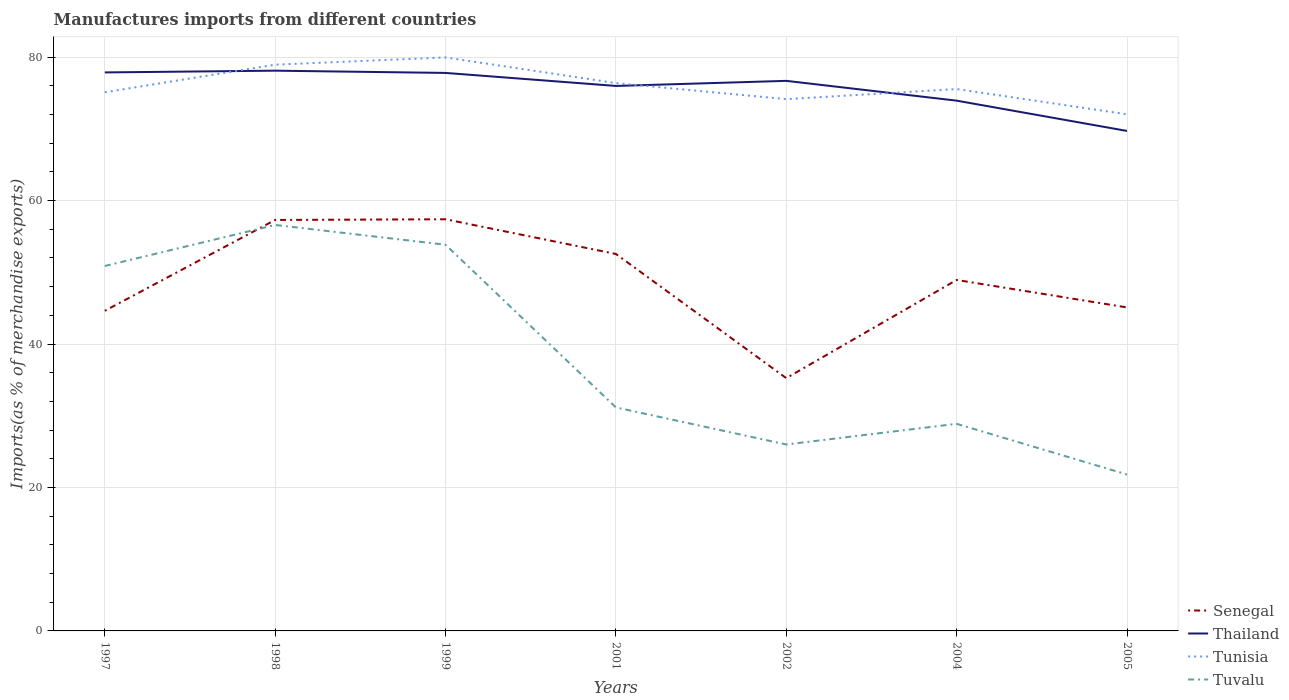Does the line corresponding to Tunisia intersect with the line corresponding to Thailand?
Provide a succinct answer. Yes. Is the number of lines equal to the number of legend labels?
Offer a terse response. Yes. Across all years, what is the maximum percentage of imports to different countries in Senegal?
Give a very brief answer. 35.24. What is the total percentage of imports to different countries in Tuvalu in the graph?
Your response must be concise. 9.35. What is the difference between the highest and the second highest percentage of imports to different countries in Thailand?
Give a very brief answer. 8.4. How many lines are there?
Offer a very short reply. 4. How many years are there in the graph?
Your answer should be compact. 7. Are the values on the major ticks of Y-axis written in scientific E-notation?
Your answer should be compact. No. Does the graph contain any zero values?
Your answer should be compact. No. Where does the legend appear in the graph?
Your answer should be very brief. Bottom right. How many legend labels are there?
Your response must be concise. 4. How are the legend labels stacked?
Give a very brief answer. Vertical. What is the title of the graph?
Provide a succinct answer. Manufactures imports from different countries. Does "Middle East & North Africa (all income levels)" appear as one of the legend labels in the graph?
Provide a succinct answer. No. What is the label or title of the X-axis?
Your answer should be very brief. Years. What is the label or title of the Y-axis?
Keep it short and to the point. Imports(as % of merchandise exports). What is the Imports(as % of merchandise exports) of Senegal in 1997?
Your response must be concise. 44.63. What is the Imports(as % of merchandise exports) in Thailand in 1997?
Ensure brevity in your answer.  77.87. What is the Imports(as % of merchandise exports) of Tunisia in 1997?
Give a very brief answer. 75.11. What is the Imports(as % of merchandise exports) in Tuvalu in 1997?
Provide a short and direct response. 50.88. What is the Imports(as % of merchandise exports) of Senegal in 1998?
Your answer should be very brief. 57.3. What is the Imports(as % of merchandise exports) of Thailand in 1998?
Make the answer very short. 78.12. What is the Imports(as % of merchandise exports) of Tunisia in 1998?
Your response must be concise. 78.95. What is the Imports(as % of merchandise exports) of Tuvalu in 1998?
Offer a very short reply. 56.6. What is the Imports(as % of merchandise exports) of Senegal in 1999?
Keep it short and to the point. 57.4. What is the Imports(as % of merchandise exports) in Thailand in 1999?
Your answer should be compact. 77.8. What is the Imports(as % of merchandise exports) of Tunisia in 1999?
Offer a terse response. 79.96. What is the Imports(as % of merchandise exports) in Tuvalu in 1999?
Keep it short and to the point. 53.85. What is the Imports(as % of merchandise exports) in Senegal in 2001?
Provide a succinct answer. 52.56. What is the Imports(as % of merchandise exports) of Thailand in 2001?
Make the answer very short. 75.99. What is the Imports(as % of merchandise exports) of Tunisia in 2001?
Offer a very short reply. 76.38. What is the Imports(as % of merchandise exports) in Tuvalu in 2001?
Ensure brevity in your answer.  31.16. What is the Imports(as % of merchandise exports) of Senegal in 2002?
Provide a succinct answer. 35.24. What is the Imports(as % of merchandise exports) in Thailand in 2002?
Your answer should be compact. 76.7. What is the Imports(as % of merchandise exports) in Tunisia in 2002?
Give a very brief answer. 74.14. What is the Imports(as % of merchandise exports) of Tuvalu in 2002?
Make the answer very short. 25.99. What is the Imports(as % of merchandise exports) of Senegal in 2004?
Offer a terse response. 48.93. What is the Imports(as % of merchandise exports) of Thailand in 2004?
Keep it short and to the point. 73.94. What is the Imports(as % of merchandise exports) in Tunisia in 2004?
Provide a succinct answer. 75.55. What is the Imports(as % of merchandise exports) of Tuvalu in 2004?
Ensure brevity in your answer.  28.88. What is the Imports(as % of merchandise exports) of Senegal in 2005?
Give a very brief answer. 45.1. What is the Imports(as % of merchandise exports) in Thailand in 2005?
Keep it short and to the point. 69.71. What is the Imports(as % of merchandise exports) of Tunisia in 2005?
Make the answer very short. 72.03. What is the Imports(as % of merchandise exports) in Tuvalu in 2005?
Your response must be concise. 21.81. Across all years, what is the maximum Imports(as % of merchandise exports) in Senegal?
Keep it short and to the point. 57.4. Across all years, what is the maximum Imports(as % of merchandise exports) in Thailand?
Keep it short and to the point. 78.12. Across all years, what is the maximum Imports(as % of merchandise exports) in Tunisia?
Your response must be concise. 79.96. Across all years, what is the maximum Imports(as % of merchandise exports) in Tuvalu?
Give a very brief answer. 56.6. Across all years, what is the minimum Imports(as % of merchandise exports) of Senegal?
Your answer should be compact. 35.24. Across all years, what is the minimum Imports(as % of merchandise exports) in Thailand?
Ensure brevity in your answer.  69.71. Across all years, what is the minimum Imports(as % of merchandise exports) in Tunisia?
Provide a succinct answer. 72.03. Across all years, what is the minimum Imports(as % of merchandise exports) of Tuvalu?
Offer a terse response. 21.81. What is the total Imports(as % of merchandise exports) in Senegal in the graph?
Ensure brevity in your answer.  341.17. What is the total Imports(as % of merchandise exports) in Thailand in the graph?
Offer a terse response. 530.12. What is the total Imports(as % of merchandise exports) in Tunisia in the graph?
Ensure brevity in your answer.  532.14. What is the total Imports(as % of merchandise exports) in Tuvalu in the graph?
Make the answer very short. 269.17. What is the difference between the Imports(as % of merchandise exports) of Senegal in 1997 and that in 1998?
Offer a terse response. -12.67. What is the difference between the Imports(as % of merchandise exports) of Thailand in 1997 and that in 1998?
Give a very brief answer. -0.24. What is the difference between the Imports(as % of merchandise exports) in Tunisia in 1997 and that in 1998?
Offer a very short reply. -3.85. What is the difference between the Imports(as % of merchandise exports) in Tuvalu in 1997 and that in 1998?
Make the answer very short. -5.72. What is the difference between the Imports(as % of merchandise exports) of Senegal in 1997 and that in 1999?
Your response must be concise. -12.76. What is the difference between the Imports(as % of merchandise exports) of Thailand in 1997 and that in 1999?
Keep it short and to the point. 0.07. What is the difference between the Imports(as % of merchandise exports) of Tunisia in 1997 and that in 1999?
Provide a succinct answer. -4.85. What is the difference between the Imports(as % of merchandise exports) of Tuvalu in 1997 and that in 1999?
Your response must be concise. -2.96. What is the difference between the Imports(as % of merchandise exports) in Senegal in 1997 and that in 2001?
Your answer should be very brief. -7.93. What is the difference between the Imports(as % of merchandise exports) in Thailand in 1997 and that in 2001?
Keep it short and to the point. 1.89. What is the difference between the Imports(as % of merchandise exports) in Tunisia in 1997 and that in 2001?
Your answer should be compact. -1.28. What is the difference between the Imports(as % of merchandise exports) in Tuvalu in 1997 and that in 2001?
Keep it short and to the point. 19.72. What is the difference between the Imports(as % of merchandise exports) of Senegal in 1997 and that in 2002?
Your answer should be compact. 9.39. What is the difference between the Imports(as % of merchandise exports) of Thailand in 1997 and that in 2002?
Provide a short and direct response. 1.18. What is the difference between the Imports(as % of merchandise exports) of Tunisia in 1997 and that in 2002?
Make the answer very short. 0.96. What is the difference between the Imports(as % of merchandise exports) of Tuvalu in 1997 and that in 2002?
Provide a succinct answer. 24.89. What is the difference between the Imports(as % of merchandise exports) in Senegal in 1997 and that in 2004?
Give a very brief answer. -4.3. What is the difference between the Imports(as % of merchandise exports) of Thailand in 1997 and that in 2004?
Provide a short and direct response. 3.94. What is the difference between the Imports(as % of merchandise exports) in Tunisia in 1997 and that in 2004?
Provide a short and direct response. -0.45. What is the difference between the Imports(as % of merchandise exports) in Tuvalu in 1997 and that in 2004?
Your response must be concise. 22. What is the difference between the Imports(as % of merchandise exports) in Senegal in 1997 and that in 2005?
Offer a very short reply. -0.47. What is the difference between the Imports(as % of merchandise exports) in Thailand in 1997 and that in 2005?
Your response must be concise. 8.16. What is the difference between the Imports(as % of merchandise exports) of Tunisia in 1997 and that in 2005?
Your response must be concise. 3.07. What is the difference between the Imports(as % of merchandise exports) in Tuvalu in 1997 and that in 2005?
Ensure brevity in your answer.  29.07. What is the difference between the Imports(as % of merchandise exports) of Senegal in 1998 and that in 1999?
Ensure brevity in your answer.  -0.09. What is the difference between the Imports(as % of merchandise exports) of Thailand in 1998 and that in 1999?
Keep it short and to the point. 0.31. What is the difference between the Imports(as % of merchandise exports) of Tunisia in 1998 and that in 1999?
Your answer should be compact. -1.01. What is the difference between the Imports(as % of merchandise exports) in Tuvalu in 1998 and that in 1999?
Your answer should be very brief. 2.76. What is the difference between the Imports(as % of merchandise exports) in Senegal in 1998 and that in 2001?
Your answer should be compact. 4.74. What is the difference between the Imports(as % of merchandise exports) in Thailand in 1998 and that in 2001?
Your answer should be compact. 2.13. What is the difference between the Imports(as % of merchandise exports) of Tunisia in 1998 and that in 2001?
Make the answer very short. 2.57. What is the difference between the Imports(as % of merchandise exports) in Tuvalu in 1998 and that in 2001?
Provide a succinct answer. 25.44. What is the difference between the Imports(as % of merchandise exports) of Senegal in 1998 and that in 2002?
Offer a very short reply. 22.06. What is the difference between the Imports(as % of merchandise exports) of Thailand in 1998 and that in 2002?
Offer a very short reply. 1.42. What is the difference between the Imports(as % of merchandise exports) of Tunisia in 1998 and that in 2002?
Give a very brief answer. 4.81. What is the difference between the Imports(as % of merchandise exports) in Tuvalu in 1998 and that in 2002?
Make the answer very short. 30.61. What is the difference between the Imports(as % of merchandise exports) of Senegal in 1998 and that in 2004?
Your answer should be very brief. 8.37. What is the difference between the Imports(as % of merchandise exports) in Thailand in 1998 and that in 2004?
Keep it short and to the point. 4.18. What is the difference between the Imports(as % of merchandise exports) of Tunisia in 1998 and that in 2004?
Give a very brief answer. 3.4. What is the difference between the Imports(as % of merchandise exports) in Tuvalu in 1998 and that in 2004?
Your response must be concise. 27.73. What is the difference between the Imports(as % of merchandise exports) of Senegal in 1998 and that in 2005?
Provide a succinct answer. 12.2. What is the difference between the Imports(as % of merchandise exports) in Thailand in 1998 and that in 2005?
Give a very brief answer. 8.4. What is the difference between the Imports(as % of merchandise exports) in Tunisia in 1998 and that in 2005?
Provide a short and direct response. 6.92. What is the difference between the Imports(as % of merchandise exports) of Tuvalu in 1998 and that in 2005?
Offer a terse response. 34.79. What is the difference between the Imports(as % of merchandise exports) of Senegal in 1999 and that in 2001?
Ensure brevity in your answer.  4.84. What is the difference between the Imports(as % of merchandise exports) in Thailand in 1999 and that in 2001?
Ensure brevity in your answer.  1.82. What is the difference between the Imports(as % of merchandise exports) in Tunisia in 1999 and that in 2001?
Provide a short and direct response. 3.58. What is the difference between the Imports(as % of merchandise exports) of Tuvalu in 1999 and that in 2001?
Your response must be concise. 22.68. What is the difference between the Imports(as % of merchandise exports) of Senegal in 1999 and that in 2002?
Provide a succinct answer. 22.15. What is the difference between the Imports(as % of merchandise exports) in Thailand in 1999 and that in 2002?
Provide a short and direct response. 1.11. What is the difference between the Imports(as % of merchandise exports) of Tunisia in 1999 and that in 2002?
Offer a very short reply. 5.82. What is the difference between the Imports(as % of merchandise exports) of Tuvalu in 1999 and that in 2002?
Your answer should be very brief. 27.85. What is the difference between the Imports(as % of merchandise exports) in Senegal in 1999 and that in 2004?
Your response must be concise. 8.46. What is the difference between the Imports(as % of merchandise exports) in Thailand in 1999 and that in 2004?
Your answer should be compact. 3.87. What is the difference between the Imports(as % of merchandise exports) of Tunisia in 1999 and that in 2004?
Make the answer very short. 4.41. What is the difference between the Imports(as % of merchandise exports) in Tuvalu in 1999 and that in 2004?
Your response must be concise. 24.97. What is the difference between the Imports(as % of merchandise exports) in Senegal in 1999 and that in 2005?
Your response must be concise. 12.29. What is the difference between the Imports(as % of merchandise exports) of Thailand in 1999 and that in 2005?
Offer a very short reply. 8.09. What is the difference between the Imports(as % of merchandise exports) of Tunisia in 1999 and that in 2005?
Ensure brevity in your answer.  7.93. What is the difference between the Imports(as % of merchandise exports) of Tuvalu in 1999 and that in 2005?
Your answer should be very brief. 32.03. What is the difference between the Imports(as % of merchandise exports) in Senegal in 2001 and that in 2002?
Keep it short and to the point. 17.31. What is the difference between the Imports(as % of merchandise exports) of Thailand in 2001 and that in 2002?
Your answer should be compact. -0.71. What is the difference between the Imports(as % of merchandise exports) of Tunisia in 2001 and that in 2002?
Your response must be concise. 2.24. What is the difference between the Imports(as % of merchandise exports) in Tuvalu in 2001 and that in 2002?
Your answer should be very brief. 5.17. What is the difference between the Imports(as % of merchandise exports) of Senegal in 2001 and that in 2004?
Make the answer very short. 3.63. What is the difference between the Imports(as % of merchandise exports) in Thailand in 2001 and that in 2004?
Your answer should be very brief. 2.05. What is the difference between the Imports(as % of merchandise exports) in Tunisia in 2001 and that in 2004?
Your answer should be very brief. 0.83. What is the difference between the Imports(as % of merchandise exports) of Tuvalu in 2001 and that in 2004?
Keep it short and to the point. 2.28. What is the difference between the Imports(as % of merchandise exports) in Senegal in 2001 and that in 2005?
Your answer should be very brief. 7.46. What is the difference between the Imports(as % of merchandise exports) in Thailand in 2001 and that in 2005?
Your answer should be compact. 6.27. What is the difference between the Imports(as % of merchandise exports) in Tunisia in 2001 and that in 2005?
Make the answer very short. 4.35. What is the difference between the Imports(as % of merchandise exports) in Tuvalu in 2001 and that in 2005?
Provide a succinct answer. 9.35. What is the difference between the Imports(as % of merchandise exports) in Senegal in 2002 and that in 2004?
Offer a very short reply. -13.69. What is the difference between the Imports(as % of merchandise exports) of Thailand in 2002 and that in 2004?
Your answer should be very brief. 2.76. What is the difference between the Imports(as % of merchandise exports) of Tunisia in 2002 and that in 2004?
Provide a short and direct response. -1.41. What is the difference between the Imports(as % of merchandise exports) in Tuvalu in 2002 and that in 2004?
Ensure brevity in your answer.  -2.88. What is the difference between the Imports(as % of merchandise exports) in Senegal in 2002 and that in 2005?
Offer a very short reply. -9.86. What is the difference between the Imports(as % of merchandise exports) in Thailand in 2002 and that in 2005?
Provide a short and direct response. 6.98. What is the difference between the Imports(as % of merchandise exports) of Tunisia in 2002 and that in 2005?
Provide a short and direct response. 2.11. What is the difference between the Imports(as % of merchandise exports) of Tuvalu in 2002 and that in 2005?
Provide a short and direct response. 4.18. What is the difference between the Imports(as % of merchandise exports) of Senegal in 2004 and that in 2005?
Offer a terse response. 3.83. What is the difference between the Imports(as % of merchandise exports) of Thailand in 2004 and that in 2005?
Offer a terse response. 4.22. What is the difference between the Imports(as % of merchandise exports) of Tunisia in 2004 and that in 2005?
Provide a succinct answer. 3.52. What is the difference between the Imports(as % of merchandise exports) in Tuvalu in 2004 and that in 2005?
Give a very brief answer. 7.07. What is the difference between the Imports(as % of merchandise exports) in Senegal in 1997 and the Imports(as % of merchandise exports) in Thailand in 1998?
Ensure brevity in your answer.  -33.48. What is the difference between the Imports(as % of merchandise exports) in Senegal in 1997 and the Imports(as % of merchandise exports) in Tunisia in 1998?
Offer a very short reply. -34.32. What is the difference between the Imports(as % of merchandise exports) of Senegal in 1997 and the Imports(as % of merchandise exports) of Tuvalu in 1998?
Your response must be concise. -11.97. What is the difference between the Imports(as % of merchandise exports) of Thailand in 1997 and the Imports(as % of merchandise exports) of Tunisia in 1998?
Provide a short and direct response. -1.08. What is the difference between the Imports(as % of merchandise exports) of Thailand in 1997 and the Imports(as % of merchandise exports) of Tuvalu in 1998?
Give a very brief answer. 21.27. What is the difference between the Imports(as % of merchandise exports) of Tunisia in 1997 and the Imports(as % of merchandise exports) of Tuvalu in 1998?
Your answer should be very brief. 18.5. What is the difference between the Imports(as % of merchandise exports) of Senegal in 1997 and the Imports(as % of merchandise exports) of Thailand in 1999?
Offer a very short reply. -33.17. What is the difference between the Imports(as % of merchandise exports) in Senegal in 1997 and the Imports(as % of merchandise exports) in Tunisia in 1999?
Your response must be concise. -35.33. What is the difference between the Imports(as % of merchandise exports) of Senegal in 1997 and the Imports(as % of merchandise exports) of Tuvalu in 1999?
Give a very brief answer. -9.21. What is the difference between the Imports(as % of merchandise exports) in Thailand in 1997 and the Imports(as % of merchandise exports) in Tunisia in 1999?
Give a very brief answer. -2.09. What is the difference between the Imports(as % of merchandise exports) of Thailand in 1997 and the Imports(as % of merchandise exports) of Tuvalu in 1999?
Give a very brief answer. 24.03. What is the difference between the Imports(as % of merchandise exports) in Tunisia in 1997 and the Imports(as % of merchandise exports) in Tuvalu in 1999?
Ensure brevity in your answer.  21.26. What is the difference between the Imports(as % of merchandise exports) in Senegal in 1997 and the Imports(as % of merchandise exports) in Thailand in 2001?
Your answer should be very brief. -31.35. What is the difference between the Imports(as % of merchandise exports) of Senegal in 1997 and the Imports(as % of merchandise exports) of Tunisia in 2001?
Keep it short and to the point. -31.75. What is the difference between the Imports(as % of merchandise exports) in Senegal in 1997 and the Imports(as % of merchandise exports) in Tuvalu in 2001?
Provide a short and direct response. 13.47. What is the difference between the Imports(as % of merchandise exports) of Thailand in 1997 and the Imports(as % of merchandise exports) of Tunisia in 2001?
Make the answer very short. 1.49. What is the difference between the Imports(as % of merchandise exports) in Thailand in 1997 and the Imports(as % of merchandise exports) in Tuvalu in 2001?
Provide a succinct answer. 46.71. What is the difference between the Imports(as % of merchandise exports) of Tunisia in 1997 and the Imports(as % of merchandise exports) of Tuvalu in 2001?
Your response must be concise. 43.95. What is the difference between the Imports(as % of merchandise exports) in Senegal in 1997 and the Imports(as % of merchandise exports) in Thailand in 2002?
Your response must be concise. -32.06. What is the difference between the Imports(as % of merchandise exports) in Senegal in 1997 and the Imports(as % of merchandise exports) in Tunisia in 2002?
Your response must be concise. -29.51. What is the difference between the Imports(as % of merchandise exports) of Senegal in 1997 and the Imports(as % of merchandise exports) of Tuvalu in 2002?
Offer a terse response. 18.64. What is the difference between the Imports(as % of merchandise exports) in Thailand in 1997 and the Imports(as % of merchandise exports) in Tunisia in 2002?
Ensure brevity in your answer.  3.73. What is the difference between the Imports(as % of merchandise exports) of Thailand in 1997 and the Imports(as % of merchandise exports) of Tuvalu in 2002?
Provide a short and direct response. 51.88. What is the difference between the Imports(as % of merchandise exports) in Tunisia in 1997 and the Imports(as % of merchandise exports) in Tuvalu in 2002?
Ensure brevity in your answer.  49.11. What is the difference between the Imports(as % of merchandise exports) in Senegal in 1997 and the Imports(as % of merchandise exports) in Thailand in 2004?
Your answer should be compact. -29.3. What is the difference between the Imports(as % of merchandise exports) in Senegal in 1997 and the Imports(as % of merchandise exports) in Tunisia in 2004?
Ensure brevity in your answer.  -30.92. What is the difference between the Imports(as % of merchandise exports) of Senegal in 1997 and the Imports(as % of merchandise exports) of Tuvalu in 2004?
Keep it short and to the point. 15.76. What is the difference between the Imports(as % of merchandise exports) of Thailand in 1997 and the Imports(as % of merchandise exports) of Tunisia in 2004?
Keep it short and to the point. 2.32. What is the difference between the Imports(as % of merchandise exports) in Thailand in 1997 and the Imports(as % of merchandise exports) in Tuvalu in 2004?
Provide a succinct answer. 49. What is the difference between the Imports(as % of merchandise exports) in Tunisia in 1997 and the Imports(as % of merchandise exports) in Tuvalu in 2004?
Your answer should be very brief. 46.23. What is the difference between the Imports(as % of merchandise exports) of Senegal in 1997 and the Imports(as % of merchandise exports) of Thailand in 2005?
Provide a short and direct response. -25.08. What is the difference between the Imports(as % of merchandise exports) in Senegal in 1997 and the Imports(as % of merchandise exports) in Tunisia in 2005?
Ensure brevity in your answer.  -27.4. What is the difference between the Imports(as % of merchandise exports) in Senegal in 1997 and the Imports(as % of merchandise exports) in Tuvalu in 2005?
Your answer should be very brief. 22.82. What is the difference between the Imports(as % of merchandise exports) of Thailand in 1997 and the Imports(as % of merchandise exports) of Tunisia in 2005?
Offer a terse response. 5.84. What is the difference between the Imports(as % of merchandise exports) in Thailand in 1997 and the Imports(as % of merchandise exports) in Tuvalu in 2005?
Provide a short and direct response. 56.06. What is the difference between the Imports(as % of merchandise exports) in Tunisia in 1997 and the Imports(as % of merchandise exports) in Tuvalu in 2005?
Your answer should be very brief. 53.3. What is the difference between the Imports(as % of merchandise exports) of Senegal in 1998 and the Imports(as % of merchandise exports) of Thailand in 1999?
Your response must be concise. -20.5. What is the difference between the Imports(as % of merchandise exports) in Senegal in 1998 and the Imports(as % of merchandise exports) in Tunisia in 1999?
Your answer should be compact. -22.66. What is the difference between the Imports(as % of merchandise exports) in Senegal in 1998 and the Imports(as % of merchandise exports) in Tuvalu in 1999?
Offer a very short reply. 3.46. What is the difference between the Imports(as % of merchandise exports) of Thailand in 1998 and the Imports(as % of merchandise exports) of Tunisia in 1999?
Make the answer very short. -1.85. What is the difference between the Imports(as % of merchandise exports) of Thailand in 1998 and the Imports(as % of merchandise exports) of Tuvalu in 1999?
Ensure brevity in your answer.  24.27. What is the difference between the Imports(as % of merchandise exports) in Tunisia in 1998 and the Imports(as % of merchandise exports) in Tuvalu in 1999?
Ensure brevity in your answer.  25.11. What is the difference between the Imports(as % of merchandise exports) of Senegal in 1998 and the Imports(as % of merchandise exports) of Thailand in 2001?
Offer a very short reply. -18.68. What is the difference between the Imports(as % of merchandise exports) in Senegal in 1998 and the Imports(as % of merchandise exports) in Tunisia in 2001?
Your answer should be very brief. -19.08. What is the difference between the Imports(as % of merchandise exports) in Senegal in 1998 and the Imports(as % of merchandise exports) in Tuvalu in 2001?
Offer a terse response. 26.14. What is the difference between the Imports(as % of merchandise exports) of Thailand in 1998 and the Imports(as % of merchandise exports) of Tunisia in 2001?
Make the answer very short. 1.73. What is the difference between the Imports(as % of merchandise exports) in Thailand in 1998 and the Imports(as % of merchandise exports) in Tuvalu in 2001?
Keep it short and to the point. 46.95. What is the difference between the Imports(as % of merchandise exports) in Tunisia in 1998 and the Imports(as % of merchandise exports) in Tuvalu in 2001?
Your answer should be very brief. 47.79. What is the difference between the Imports(as % of merchandise exports) in Senegal in 1998 and the Imports(as % of merchandise exports) in Thailand in 2002?
Make the answer very short. -19.39. What is the difference between the Imports(as % of merchandise exports) in Senegal in 1998 and the Imports(as % of merchandise exports) in Tunisia in 2002?
Keep it short and to the point. -16.84. What is the difference between the Imports(as % of merchandise exports) in Senegal in 1998 and the Imports(as % of merchandise exports) in Tuvalu in 2002?
Provide a succinct answer. 31.31. What is the difference between the Imports(as % of merchandise exports) in Thailand in 1998 and the Imports(as % of merchandise exports) in Tunisia in 2002?
Give a very brief answer. 3.97. What is the difference between the Imports(as % of merchandise exports) of Thailand in 1998 and the Imports(as % of merchandise exports) of Tuvalu in 2002?
Keep it short and to the point. 52.12. What is the difference between the Imports(as % of merchandise exports) in Tunisia in 1998 and the Imports(as % of merchandise exports) in Tuvalu in 2002?
Your answer should be compact. 52.96. What is the difference between the Imports(as % of merchandise exports) of Senegal in 1998 and the Imports(as % of merchandise exports) of Thailand in 2004?
Keep it short and to the point. -16.63. What is the difference between the Imports(as % of merchandise exports) of Senegal in 1998 and the Imports(as % of merchandise exports) of Tunisia in 2004?
Make the answer very short. -18.25. What is the difference between the Imports(as % of merchandise exports) in Senegal in 1998 and the Imports(as % of merchandise exports) in Tuvalu in 2004?
Make the answer very short. 28.43. What is the difference between the Imports(as % of merchandise exports) of Thailand in 1998 and the Imports(as % of merchandise exports) of Tunisia in 2004?
Give a very brief answer. 2.56. What is the difference between the Imports(as % of merchandise exports) in Thailand in 1998 and the Imports(as % of merchandise exports) in Tuvalu in 2004?
Provide a succinct answer. 49.24. What is the difference between the Imports(as % of merchandise exports) of Tunisia in 1998 and the Imports(as % of merchandise exports) of Tuvalu in 2004?
Ensure brevity in your answer.  50.08. What is the difference between the Imports(as % of merchandise exports) in Senegal in 1998 and the Imports(as % of merchandise exports) in Thailand in 2005?
Give a very brief answer. -12.41. What is the difference between the Imports(as % of merchandise exports) of Senegal in 1998 and the Imports(as % of merchandise exports) of Tunisia in 2005?
Make the answer very short. -14.73. What is the difference between the Imports(as % of merchandise exports) in Senegal in 1998 and the Imports(as % of merchandise exports) in Tuvalu in 2005?
Provide a succinct answer. 35.49. What is the difference between the Imports(as % of merchandise exports) in Thailand in 1998 and the Imports(as % of merchandise exports) in Tunisia in 2005?
Ensure brevity in your answer.  6.08. What is the difference between the Imports(as % of merchandise exports) of Thailand in 1998 and the Imports(as % of merchandise exports) of Tuvalu in 2005?
Your response must be concise. 56.31. What is the difference between the Imports(as % of merchandise exports) in Tunisia in 1998 and the Imports(as % of merchandise exports) in Tuvalu in 2005?
Offer a very short reply. 57.14. What is the difference between the Imports(as % of merchandise exports) in Senegal in 1999 and the Imports(as % of merchandise exports) in Thailand in 2001?
Your answer should be compact. -18.59. What is the difference between the Imports(as % of merchandise exports) of Senegal in 1999 and the Imports(as % of merchandise exports) of Tunisia in 2001?
Keep it short and to the point. -18.99. What is the difference between the Imports(as % of merchandise exports) of Senegal in 1999 and the Imports(as % of merchandise exports) of Tuvalu in 2001?
Give a very brief answer. 26.24. What is the difference between the Imports(as % of merchandise exports) in Thailand in 1999 and the Imports(as % of merchandise exports) in Tunisia in 2001?
Provide a succinct answer. 1.42. What is the difference between the Imports(as % of merchandise exports) of Thailand in 1999 and the Imports(as % of merchandise exports) of Tuvalu in 2001?
Your response must be concise. 46.64. What is the difference between the Imports(as % of merchandise exports) of Tunisia in 1999 and the Imports(as % of merchandise exports) of Tuvalu in 2001?
Offer a terse response. 48.8. What is the difference between the Imports(as % of merchandise exports) in Senegal in 1999 and the Imports(as % of merchandise exports) in Thailand in 2002?
Provide a short and direct response. -19.3. What is the difference between the Imports(as % of merchandise exports) in Senegal in 1999 and the Imports(as % of merchandise exports) in Tunisia in 2002?
Offer a terse response. -16.75. What is the difference between the Imports(as % of merchandise exports) of Senegal in 1999 and the Imports(as % of merchandise exports) of Tuvalu in 2002?
Your answer should be compact. 31.4. What is the difference between the Imports(as % of merchandise exports) in Thailand in 1999 and the Imports(as % of merchandise exports) in Tunisia in 2002?
Your answer should be compact. 3.66. What is the difference between the Imports(as % of merchandise exports) of Thailand in 1999 and the Imports(as % of merchandise exports) of Tuvalu in 2002?
Provide a succinct answer. 51.81. What is the difference between the Imports(as % of merchandise exports) in Tunisia in 1999 and the Imports(as % of merchandise exports) in Tuvalu in 2002?
Provide a succinct answer. 53.97. What is the difference between the Imports(as % of merchandise exports) in Senegal in 1999 and the Imports(as % of merchandise exports) in Thailand in 2004?
Provide a succinct answer. -16.54. What is the difference between the Imports(as % of merchandise exports) in Senegal in 1999 and the Imports(as % of merchandise exports) in Tunisia in 2004?
Make the answer very short. -18.16. What is the difference between the Imports(as % of merchandise exports) of Senegal in 1999 and the Imports(as % of merchandise exports) of Tuvalu in 2004?
Your answer should be very brief. 28.52. What is the difference between the Imports(as % of merchandise exports) in Thailand in 1999 and the Imports(as % of merchandise exports) in Tunisia in 2004?
Your answer should be very brief. 2.25. What is the difference between the Imports(as % of merchandise exports) in Thailand in 1999 and the Imports(as % of merchandise exports) in Tuvalu in 2004?
Provide a succinct answer. 48.93. What is the difference between the Imports(as % of merchandise exports) in Tunisia in 1999 and the Imports(as % of merchandise exports) in Tuvalu in 2004?
Your answer should be compact. 51.09. What is the difference between the Imports(as % of merchandise exports) in Senegal in 1999 and the Imports(as % of merchandise exports) in Thailand in 2005?
Your answer should be compact. -12.32. What is the difference between the Imports(as % of merchandise exports) in Senegal in 1999 and the Imports(as % of merchandise exports) in Tunisia in 2005?
Your answer should be very brief. -14.64. What is the difference between the Imports(as % of merchandise exports) in Senegal in 1999 and the Imports(as % of merchandise exports) in Tuvalu in 2005?
Give a very brief answer. 35.59. What is the difference between the Imports(as % of merchandise exports) of Thailand in 1999 and the Imports(as % of merchandise exports) of Tunisia in 2005?
Your answer should be very brief. 5.77. What is the difference between the Imports(as % of merchandise exports) in Thailand in 1999 and the Imports(as % of merchandise exports) in Tuvalu in 2005?
Provide a short and direct response. 55.99. What is the difference between the Imports(as % of merchandise exports) of Tunisia in 1999 and the Imports(as % of merchandise exports) of Tuvalu in 2005?
Provide a succinct answer. 58.15. What is the difference between the Imports(as % of merchandise exports) in Senegal in 2001 and the Imports(as % of merchandise exports) in Thailand in 2002?
Offer a terse response. -24.14. What is the difference between the Imports(as % of merchandise exports) in Senegal in 2001 and the Imports(as % of merchandise exports) in Tunisia in 2002?
Keep it short and to the point. -21.59. What is the difference between the Imports(as % of merchandise exports) of Senegal in 2001 and the Imports(as % of merchandise exports) of Tuvalu in 2002?
Your answer should be very brief. 26.57. What is the difference between the Imports(as % of merchandise exports) of Thailand in 2001 and the Imports(as % of merchandise exports) of Tunisia in 2002?
Give a very brief answer. 1.84. What is the difference between the Imports(as % of merchandise exports) in Thailand in 2001 and the Imports(as % of merchandise exports) in Tuvalu in 2002?
Provide a short and direct response. 49.99. What is the difference between the Imports(as % of merchandise exports) of Tunisia in 2001 and the Imports(as % of merchandise exports) of Tuvalu in 2002?
Keep it short and to the point. 50.39. What is the difference between the Imports(as % of merchandise exports) of Senegal in 2001 and the Imports(as % of merchandise exports) of Thailand in 2004?
Ensure brevity in your answer.  -21.38. What is the difference between the Imports(as % of merchandise exports) in Senegal in 2001 and the Imports(as % of merchandise exports) in Tunisia in 2004?
Provide a short and direct response. -22.99. What is the difference between the Imports(as % of merchandise exports) of Senegal in 2001 and the Imports(as % of merchandise exports) of Tuvalu in 2004?
Give a very brief answer. 23.68. What is the difference between the Imports(as % of merchandise exports) of Thailand in 2001 and the Imports(as % of merchandise exports) of Tunisia in 2004?
Your answer should be very brief. 0.43. What is the difference between the Imports(as % of merchandise exports) of Thailand in 2001 and the Imports(as % of merchandise exports) of Tuvalu in 2004?
Your response must be concise. 47.11. What is the difference between the Imports(as % of merchandise exports) of Tunisia in 2001 and the Imports(as % of merchandise exports) of Tuvalu in 2004?
Your answer should be compact. 47.51. What is the difference between the Imports(as % of merchandise exports) in Senegal in 2001 and the Imports(as % of merchandise exports) in Thailand in 2005?
Provide a succinct answer. -17.15. What is the difference between the Imports(as % of merchandise exports) of Senegal in 2001 and the Imports(as % of merchandise exports) of Tunisia in 2005?
Your answer should be very brief. -19.47. What is the difference between the Imports(as % of merchandise exports) in Senegal in 2001 and the Imports(as % of merchandise exports) in Tuvalu in 2005?
Provide a short and direct response. 30.75. What is the difference between the Imports(as % of merchandise exports) in Thailand in 2001 and the Imports(as % of merchandise exports) in Tunisia in 2005?
Keep it short and to the point. 3.95. What is the difference between the Imports(as % of merchandise exports) of Thailand in 2001 and the Imports(as % of merchandise exports) of Tuvalu in 2005?
Make the answer very short. 54.18. What is the difference between the Imports(as % of merchandise exports) of Tunisia in 2001 and the Imports(as % of merchandise exports) of Tuvalu in 2005?
Make the answer very short. 54.57. What is the difference between the Imports(as % of merchandise exports) in Senegal in 2002 and the Imports(as % of merchandise exports) in Thailand in 2004?
Make the answer very short. -38.69. What is the difference between the Imports(as % of merchandise exports) in Senegal in 2002 and the Imports(as % of merchandise exports) in Tunisia in 2004?
Keep it short and to the point. -40.31. What is the difference between the Imports(as % of merchandise exports) of Senegal in 2002 and the Imports(as % of merchandise exports) of Tuvalu in 2004?
Keep it short and to the point. 6.37. What is the difference between the Imports(as % of merchandise exports) in Thailand in 2002 and the Imports(as % of merchandise exports) in Tunisia in 2004?
Offer a very short reply. 1.14. What is the difference between the Imports(as % of merchandise exports) in Thailand in 2002 and the Imports(as % of merchandise exports) in Tuvalu in 2004?
Keep it short and to the point. 47.82. What is the difference between the Imports(as % of merchandise exports) in Tunisia in 2002 and the Imports(as % of merchandise exports) in Tuvalu in 2004?
Your answer should be very brief. 45.27. What is the difference between the Imports(as % of merchandise exports) of Senegal in 2002 and the Imports(as % of merchandise exports) of Thailand in 2005?
Keep it short and to the point. -34.47. What is the difference between the Imports(as % of merchandise exports) of Senegal in 2002 and the Imports(as % of merchandise exports) of Tunisia in 2005?
Ensure brevity in your answer.  -36.79. What is the difference between the Imports(as % of merchandise exports) of Senegal in 2002 and the Imports(as % of merchandise exports) of Tuvalu in 2005?
Your answer should be compact. 13.43. What is the difference between the Imports(as % of merchandise exports) of Thailand in 2002 and the Imports(as % of merchandise exports) of Tunisia in 2005?
Make the answer very short. 4.66. What is the difference between the Imports(as % of merchandise exports) in Thailand in 2002 and the Imports(as % of merchandise exports) in Tuvalu in 2005?
Provide a succinct answer. 54.89. What is the difference between the Imports(as % of merchandise exports) in Tunisia in 2002 and the Imports(as % of merchandise exports) in Tuvalu in 2005?
Give a very brief answer. 52.33. What is the difference between the Imports(as % of merchandise exports) of Senegal in 2004 and the Imports(as % of merchandise exports) of Thailand in 2005?
Give a very brief answer. -20.78. What is the difference between the Imports(as % of merchandise exports) in Senegal in 2004 and the Imports(as % of merchandise exports) in Tunisia in 2005?
Give a very brief answer. -23.1. What is the difference between the Imports(as % of merchandise exports) in Senegal in 2004 and the Imports(as % of merchandise exports) in Tuvalu in 2005?
Your answer should be very brief. 27.12. What is the difference between the Imports(as % of merchandise exports) in Thailand in 2004 and the Imports(as % of merchandise exports) in Tunisia in 2005?
Offer a very short reply. 1.9. What is the difference between the Imports(as % of merchandise exports) in Thailand in 2004 and the Imports(as % of merchandise exports) in Tuvalu in 2005?
Your response must be concise. 52.12. What is the difference between the Imports(as % of merchandise exports) of Tunisia in 2004 and the Imports(as % of merchandise exports) of Tuvalu in 2005?
Keep it short and to the point. 53.74. What is the average Imports(as % of merchandise exports) of Senegal per year?
Keep it short and to the point. 48.74. What is the average Imports(as % of merchandise exports) in Thailand per year?
Your response must be concise. 75.73. What is the average Imports(as % of merchandise exports) in Tunisia per year?
Your response must be concise. 76.02. What is the average Imports(as % of merchandise exports) in Tuvalu per year?
Provide a short and direct response. 38.45. In the year 1997, what is the difference between the Imports(as % of merchandise exports) of Senegal and Imports(as % of merchandise exports) of Thailand?
Your response must be concise. -33.24. In the year 1997, what is the difference between the Imports(as % of merchandise exports) of Senegal and Imports(as % of merchandise exports) of Tunisia?
Your response must be concise. -30.47. In the year 1997, what is the difference between the Imports(as % of merchandise exports) in Senegal and Imports(as % of merchandise exports) in Tuvalu?
Provide a short and direct response. -6.25. In the year 1997, what is the difference between the Imports(as % of merchandise exports) in Thailand and Imports(as % of merchandise exports) in Tunisia?
Ensure brevity in your answer.  2.77. In the year 1997, what is the difference between the Imports(as % of merchandise exports) of Thailand and Imports(as % of merchandise exports) of Tuvalu?
Ensure brevity in your answer.  26.99. In the year 1997, what is the difference between the Imports(as % of merchandise exports) in Tunisia and Imports(as % of merchandise exports) in Tuvalu?
Make the answer very short. 24.23. In the year 1998, what is the difference between the Imports(as % of merchandise exports) of Senegal and Imports(as % of merchandise exports) of Thailand?
Provide a succinct answer. -20.81. In the year 1998, what is the difference between the Imports(as % of merchandise exports) of Senegal and Imports(as % of merchandise exports) of Tunisia?
Make the answer very short. -21.65. In the year 1998, what is the difference between the Imports(as % of merchandise exports) in Senegal and Imports(as % of merchandise exports) in Tuvalu?
Give a very brief answer. 0.7. In the year 1998, what is the difference between the Imports(as % of merchandise exports) of Thailand and Imports(as % of merchandise exports) of Tunisia?
Your response must be concise. -0.84. In the year 1998, what is the difference between the Imports(as % of merchandise exports) of Thailand and Imports(as % of merchandise exports) of Tuvalu?
Your response must be concise. 21.51. In the year 1998, what is the difference between the Imports(as % of merchandise exports) in Tunisia and Imports(as % of merchandise exports) in Tuvalu?
Your answer should be compact. 22.35. In the year 1999, what is the difference between the Imports(as % of merchandise exports) of Senegal and Imports(as % of merchandise exports) of Thailand?
Your response must be concise. -20.41. In the year 1999, what is the difference between the Imports(as % of merchandise exports) in Senegal and Imports(as % of merchandise exports) in Tunisia?
Your answer should be very brief. -22.57. In the year 1999, what is the difference between the Imports(as % of merchandise exports) of Senegal and Imports(as % of merchandise exports) of Tuvalu?
Keep it short and to the point. 3.55. In the year 1999, what is the difference between the Imports(as % of merchandise exports) of Thailand and Imports(as % of merchandise exports) of Tunisia?
Offer a very short reply. -2.16. In the year 1999, what is the difference between the Imports(as % of merchandise exports) in Thailand and Imports(as % of merchandise exports) in Tuvalu?
Offer a terse response. 23.96. In the year 1999, what is the difference between the Imports(as % of merchandise exports) in Tunisia and Imports(as % of merchandise exports) in Tuvalu?
Your answer should be compact. 26.12. In the year 2001, what is the difference between the Imports(as % of merchandise exports) in Senegal and Imports(as % of merchandise exports) in Thailand?
Offer a very short reply. -23.43. In the year 2001, what is the difference between the Imports(as % of merchandise exports) of Senegal and Imports(as % of merchandise exports) of Tunisia?
Your answer should be very brief. -23.82. In the year 2001, what is the difference between the Imports(as % of merchandise exports) in Senegal and Imports(as % of merchandise exports) in Tuvalu?
Offer a very short reply. 21.4. In the year 2001, what is the difference between the Imports(as % of merchandise exports) of Thailand and Imports(as % of merchandise exports) of Tunisia?
Your answer should be very brief. -0.4. In the year 2001, what is the difference between the Imports(as % of merchandise exports) in Thailand and Imports(as % of merchandise exports) in Tuvalu?
Keep it short and to the point. 44.83. In the year 2001, what is the difference between the Imports(as % of merchandise exports) of Tunisia and Imports(as % of merchandise exports) of Tuvalu?
Ensure brevity in your answer.  45.22. In the year 2002, what is the difference between the Imports(as % of merchandise exports) in Senegal and Imports(as % of merchandise exports) in Thailand?
Offer a terse response. -41.45. In the year 2002, what is the difference between the Imports(as % of merchandise exports) in Senegal and Imports(as % of merchandise exports) in Tunisia?
Offer a terse response. -38.9. In the year 2002, what is the difference between the Imports(as % of merchandise exports) in Senegal and Imports(as % of merchandise exports) in Tuvalu?
Give a very brief answer. 9.25. In the year 2002, what is the difference between the Imports(as % of merchandise exports) of Thailand and Imports(as % of merchandise exports) of Tunisia?
Ensure brevity in your answer.  2.55. In the year 2002, what is the difference between the Imports(as % of merchandise exports) in Thailand and Imports(as % of merchandise exports) in Tuvalu?
Offer a very short reply. 50.7. In the year 2002, what is the difference between the Imports(as % of merchandise exports) of Tunisia and Imports(as % of merchandise exports) of Tuvalu?
Your answer should be compact. 48.15. In the year 2004, what is the difference between the Imports(as % of merchandise exports) of Senegal and Imports(as % of merchandise exports) of Thailand?
Keep it short and to the point. -25. In the year 2004, what is the difference between the Imports(as % of merchandise exports) of Senegal and Imports(as % of merchandise exports) of Tunisia?
Your answer should be compact. -26.62. In the year 2004, what is the difference between the Imports(as % of merchandise exports) in Senegal and Imports(as % of merchandise exports) in Tuvalu?
Give a very brief answer. 20.06. In the year 2004, what is the difference between the Imports(as % of merchandise exports) in Thailand and Imports(as % of merchandise exports) in Tunisia?
Provide a short and direct response. -1.62. In the year 2004, what is the difference between the Imports(as % of merchandise exports) in Thailand and Imports(as % of merchandise exports) in Tuvalu?
Give a very brief answer. 45.06. In the year 2004, what is the difference between the Imports(as % of merchandise exports) of Tunisia and Imports(as % of merchandise exports) of Tuvalu?
Your answer should be compact. 46.68. In the year 2005, what is the difference between the Imports(as % of merchandise exports) of Senegal and Imports(as % of merchandise exports) of Thailand?
Offer a terse response. -24.61. In the year 2005, what is the difference between the Imports(as % of merchandise exports) in Senegal and Imports(as % of merchandise exports) in Tunisia?
Offer a terse response. -26.93. In the year 2005, what is the difference between the Imports(as % of merchandise exports) in Senegal and Imports(as % of merchandise exports) in Tuvalu?
Offer a very short reply. 23.29. In the year 2005, what is the difference between the Imports(as % of merchandise exports) in Thailand and Imports(as % of merchandise exports) in Tunisia?
Make the answer very short. -2.32. In the year 2005, what is the difference between the Imports(as % of merchandise exports) of Thailand and Imports(as % of merchandise exports) of Tuvalu?
Your answer should be very brief. 47.9. In the year 2005, what is the difference between the Imports(as % of merchandise exports) of Tunisia and Imports(as % of merchandise exports) of Tuvalu?
Your answer should be very brief. 50.22. What is the ratio of the Imports(as % of merchandise exports) of Senegal in 1997 to that in 1998?
Offer a terse response. 0.78. What is the ratio of the Imports(as % of merchandise exports) in Tunisia in 1997 to that in 1998?
Keep it short and to the point. 0.95. What is the ratio of the Imports(as % of merchandise exports) of Tuvalu in 1997 to that in 1998?
Provide a succinct answer. 0.9. What is the ratio of the Imports(as % of merchandise exports) of Senegal in 1997 to that in 1999?
Make the answer very short. 0.78. What is the ratio of the Imports(as % of merchandise exports) in Thailand in 1997 to that in 1999?
Keep it short and to the point. 1. What is the ratio of the Imports(as % of merchandise exports) in Tunisia in 1997 to that in 1999?
Make the answer very short. 0.94. What is the ratio of the Imports(as % of merchandise exports) of Tuvalu in 1997 to that in 1999?
Keep it short and to the point. 0.94. What is the ratio of the Imports(as % of merchandise exports) in Senegal in 1997 to that in 2001?
Make the answer very short. 0.85. What is the ratio of the Imports(as % of merchandise exports) in Thailand in 1997 to that in 2001?
Your answer should be very brief. 1.02. What is the ratio of the Imports(as % of merchandise exports) in Tunisia in 1997 to that in 2001?
Ensure brevity in your answer.  0.98. What is the ratio of the Imports(as % of merchandise exports) in Tuvalu in 1997 to that in 2001?
Give a very brief answer. 1.63. What is the ratio of the Imports(as % of merchandise exports) in Senegal in 1997 to that in 2002?
Make the answer very short. 1.27. What is the ratio of the Imports(as % of merchandise exports) of Thailand in 1997 to that in 2002?
Make the answer very short. 1.02. What is the ratio of the Imports(as % of merchandise exports) of Tunisia in 1997 to that in 2002?
Make the answer very short. 1.01. What is the ratio of the Imports(as % of merchandise exports) in Tuvalu in 1997 to that in 2002?
Your answer should be very brief. 1.96. What is the ratio of the Imports(as % of merchandise exports) of Senegal in 1997 to that in 2004?
Your answer should be very brief. 0.91. What is the ratio of the Imports(as % of merchandise exports) of Thailand in 1997 to that in 2004?
Your answer should be very brief. 1.05. What is the ratio of the Imports(as % of merchandise exports) in Tuvalu in 1997 to that in 2004?
Provide a succinct answer. 1.76. What is the ratio of the Imports(as % of merchandise exports) in Thailand in 1997 to that in 2005?
Provide a succinct answer. 1.12. What is the ratio of the Imports(as % of merchandise exports) in Tunisia in 1997 to that in 2005?
Ensure brevity in your answer.  1.04. What is the ratio of the Imports(as % of merchandise exports) in Tuvalu in 1997 to that in 2005?
Your answer should be very brief. 2.33. What is the ratio of the Imports(as % of merchandise exports) of Senegal in 1998 to that in 1999?
Keep it short and to the point. 1. What is the ratio of the Imports(as % of merchandise exports) of Thailand in 1998 to that in 1999?
Provide a succinct answer. 1. What is the ratio of the Imports(as % of merchandise exports) in Tunisia in 1998 to that in 1999?
Your answer should be compact. 0.99. What is the ratio of the Imports(as % of merchandise exports) in Tuvalu in 1998 to that in 1999?
Keep it short and to the point. 1.05. What is the ratio of the Imports(as % of merchandise exports) of Senegal in 1998 to that in 2001?
Make the answer very short. 1.09. What is the ratio of the Imports(as % of merchandise exports) in Thailand in 1998 to that in 2001?
Give a very brief answer. 1.03. What is the ratio of the Imports(as % of merchandise exports) in Tunisia in 1998 to that in 2001?
Provide a short and direct response. 1.03. What is the ratio of the Imports(as % of merchandise exports) of Tuvalu in 1998 to that in 2001?
Make the answer very short. 1.82. What is the ratio of the Imports(as % of merchandise exports) of Senegal in 1998 to that in 2002?
Give a very brief answer. 1.63. What is the ratio of the Imports(as % of merchandise exports) in Thailand in 1998 to that in 2002?
Keep it short and to the point. 1.02. What is the ratio of the Imports(as % of merchandise exports) in Tunisia in 1998 to that in 2002?
Ensure brevity in your answer.  1.06. What is the ratio of the Imports(as % of merchandise exports) in Tuvalu in 1998 to that in 2002?
Keep it short and to the point. 2.18. What is the ratio of the Imports(as % of merchandise exports) in Senegal in 1998 to that in 2004?
Provide a short and direct response. 1.17. What is the ratio of the Imports(as % of merchandise exports) of Thailand in 1998 to that in 2004?
Your answer should be compact. 1.06. What is the ratio of the Imports(as % of merchandise exports) of Tunisia in 1998 to that in 2004?
Provide a short and direct response. 1.04. What is the ratio of the Imports(as % of merchandise exports) of Tuvalu in 1998 to that in 2004?
Provide a short and direct response. 1.96. What is the ratio of the Imports(as % of merchandise exports) in Senegal in 1998 to that in 2005?
Offer a very short reply. 1.27. What is the ratio of the Imports(as % of merchandise exports) in Thailand in 1998 to that in 2005?
Provide a succinct answer. 1.12. What is the ratio of the Imports(as % of merchandise exports) of Tunisia in 1998 to that in 2005?
Keep it short and to the point. 1.1. What is the ratio of the Imports(as % of merchandise exports) in Tuvalu in 1998 to that in 2005?
Keep it short and to the point. 2.6. What is the ratio of the Imports(as % of merchandise exports) of Senegal in 1999 to that in 2001?
Your response must be concise. 1.09. What is the ratio of the Imports(as % of merchandise exports) in Thailand in 1999 to that in 2001?
Provide a succinct answer. 1.02. What is the ratio of the Imports(as % of merchandise exports) of Tunisia in 1999 to that in 2001?
Ensure brevity in your answer.  1.05. What is the ratio of the Imports(as % of merchandise exports) of Tuvalu in 1999 to that in 2001?
Your answer should be very brief. 1.73. What is the ratio of the Imports(as % of merchandise exports) of Senegal in 1999 to that in 2002?
Ensure brevity in your answer.  1.63. What is the ratio of the Imports(as % of merchandise exports) in Thailand in 1999 to that in 2002?
Provide a succinct answer. 1.01. What is the ratio of the Imports(as % of merchandise exports) in Tunisia in 1999 to that in 2002?
Make the answer very short. 1.08. What is the ratio of the Imports(as % of merchandise exports) in Tuvalu in 1999 to that in 2002?
Offer a very short reply. 2.07. What is the ratio of the Imports(as % of merchandise exports) of Senegal in 1999 to that in 2004?
Your response must be concise. 1.17. What is the ratio of the Imports(as % of merchandise exports) of Thailand in 1999 to that in 2004?
Your answer should be very brief. 1.05. What is the ratio of the Imports(as % of merchandise exports) of Tunisia in 1999 to that in 2004?
Make the answer very short. 1.06. What is the ratio of the Imports(as % of merchandise exports) of Tuvalu in 1999 to that in 2004?
Keep it short and to the point. 1.86. What is the ratio of the Imports(as % of merchandise exports) in Senegal in 1999 to that in 2005?
Provide a short and direct response. 1.27. What is the ratio of the Imports(as % of merchandise exports) in Thailand in 1999 to that in 2005?
Your answer should be compact. 1.12. What is the ratio of the Imports(as % of merchandise exports) of Tunisia in 1999 to that in 2005?
Give a very brief answer. 1.11. What is the ratio of the Imports(as % of merchandise exports) of Tuvalu in 1999 to that in 2005?
Keep it short and to the point. 2.47. What is the ratio of the Imports(as % of merchandise exports) in Senegal in 2001 to that in 2002?
Your answer should be very brief. 1.49. What is the ratio of the Imports(as % of merchandise exports) in Thailand in 2001 to that in 2002?
Your answer should be very brief. 0.99. What is the ratio of the Imports(as % of merchandise exports) in Tunisia in 2001 to that in 2002?
Offer a terse response. 1.03. What is the ratio of the Imports(as % of merchandise exports) of Tuvalu in 2001 to that in 2002?
Offer a terse response. 1.2. What is the ratio of the Imports(as % of merchandise exports) of Senegal in 2001 to that in 2004?
Provide a succinct answer. 1.07. What is the ratio of the Imports(as % of merchandise exports) in Thailand in 2001 to that in 2004?
Make the answer very short. 1.03. What is the ratio of the Imports(as % of merchandise exports) of Tuvalu in 2001 to that in 2004?
Offer a terse response. 1.08. What is the ratio of the Imports(as % of merchandise exports) in Senegal in 2001 to that in 2005?
Your answer should be very brief. 1.17. What is the ratio of the Imports(as % of merchandise exports) in Thailand in 2001 to that in 2005?
Make the answer very short. 1.09. What is the ratio of the Imports(as % of merchandise exports) of Tunisia in 2001 to that in 2005?
Give a very brief answer. 1.06. What is the ratio of the Imports(as % of merchandise exports) of Tuvalu in 2001 to that in 2005?
Make the answer very short. 1.43. What is the ratio of the Imports(as % of merchandise exports) of Senegal in 2002 to that in 2004?
Give a very brief answer. 0.72. What is the ratio of the Imports(as % of merchandise exports) of Thailand in 2002 to that in 2004?
Provide a succinct answer. 1.04. What is the ratio of the Imports(as % of merchandise exports) of Tunisia in 2002 to that in 2004?
Make the answer very short. 0.98. What is the ratio of the Imports(as % of merchandise exports) in Tuvalu in 2002 to that in 2004?
Give a very brief answer. 0.9. What is the ratio of the Imports(as % of merchandise exports) in Senegal in 2002 to that in 2005?
Provide a succinct answer. 0.78. What is the ratio of the Imports(as % of merchandise exports) of Thailand in 2002 to that in 2005?
Ensure brevity in your answer.  1.1. What is the ratio of the Imports(as % of merchandise exports) of Tunisia in 2002 to that in 2005?
Your response must be concise. 1.03. What is the ratio of the Imports(as % of merchandise exports) in Tuvalu in 2002 to that in 2005?
Your response must be concise. 1.19. What is the ratio of the Imports(as % of merchandise exports) in Senegal in 2004 to that in 2005?
Ensure brevity in your answer.  1.08. What is the ratio of the Imports(as % of merchandise exports) in Thailand in 2004 to that in 2005?
Your response must be concise. 1.06. What is the ratio of the Imports(as % of merchandise exports) of Tunisia in 2004 to that in 2005?
Your response must be concise. 1.05. What is the ratio of the Imports(as % of merchandise exports) in Tuvalu in 2004 to that in 2005?
Keep it short and to the point. 1.32. What is the difference between the highest and the second highest Imports(as % of merchandise exports) in Senegal?
Offer a terse response. 0.09. What is the difference between the highest and the second highest Imports(as % of merchandise exports) of Thailand?
Keep it short and to the point. 0.24. What is the difference between the highest and the second highest Imports(as % of merchandise exports) in Tunisia?
Your answer should be very brief. 1.01. What is the difference between the highest and the second highest Imports(as % of merchandise exports) in Tuvalu?
Give a very brief answer. 2.76. What is the difference between the highest and the lowest Imports(as % of merchandise exports) in Senegal?
Offer a very short reply. 22.15. What is the difference between the highest and the lowest Imports(as % of merchandise exports) in Thailand?
Give a very brief answer. 8.4. What is the difference between the highest and the lowest Imports(as % of merchandise exports) of Tunisia?
Ensure brevity in your answer.  7.93. What is the difference between the highest and the lowest Imports(as % of merchandise exports) of Tuvalu?
Your answer should be very brief. 34.79. 